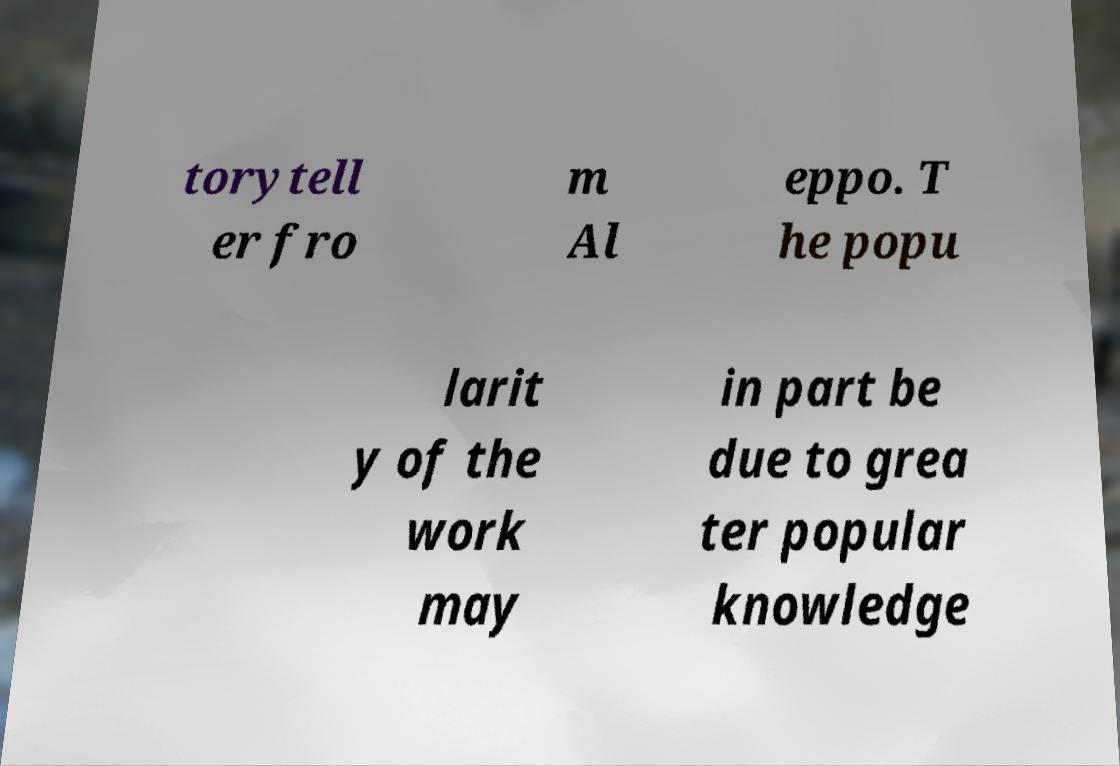What messages or text are displayed in this image? I need them in a readable, typed format. torytell er fro m Al eppo. T he popu larit y of the work may in part be due to grea ter popular knowledge 